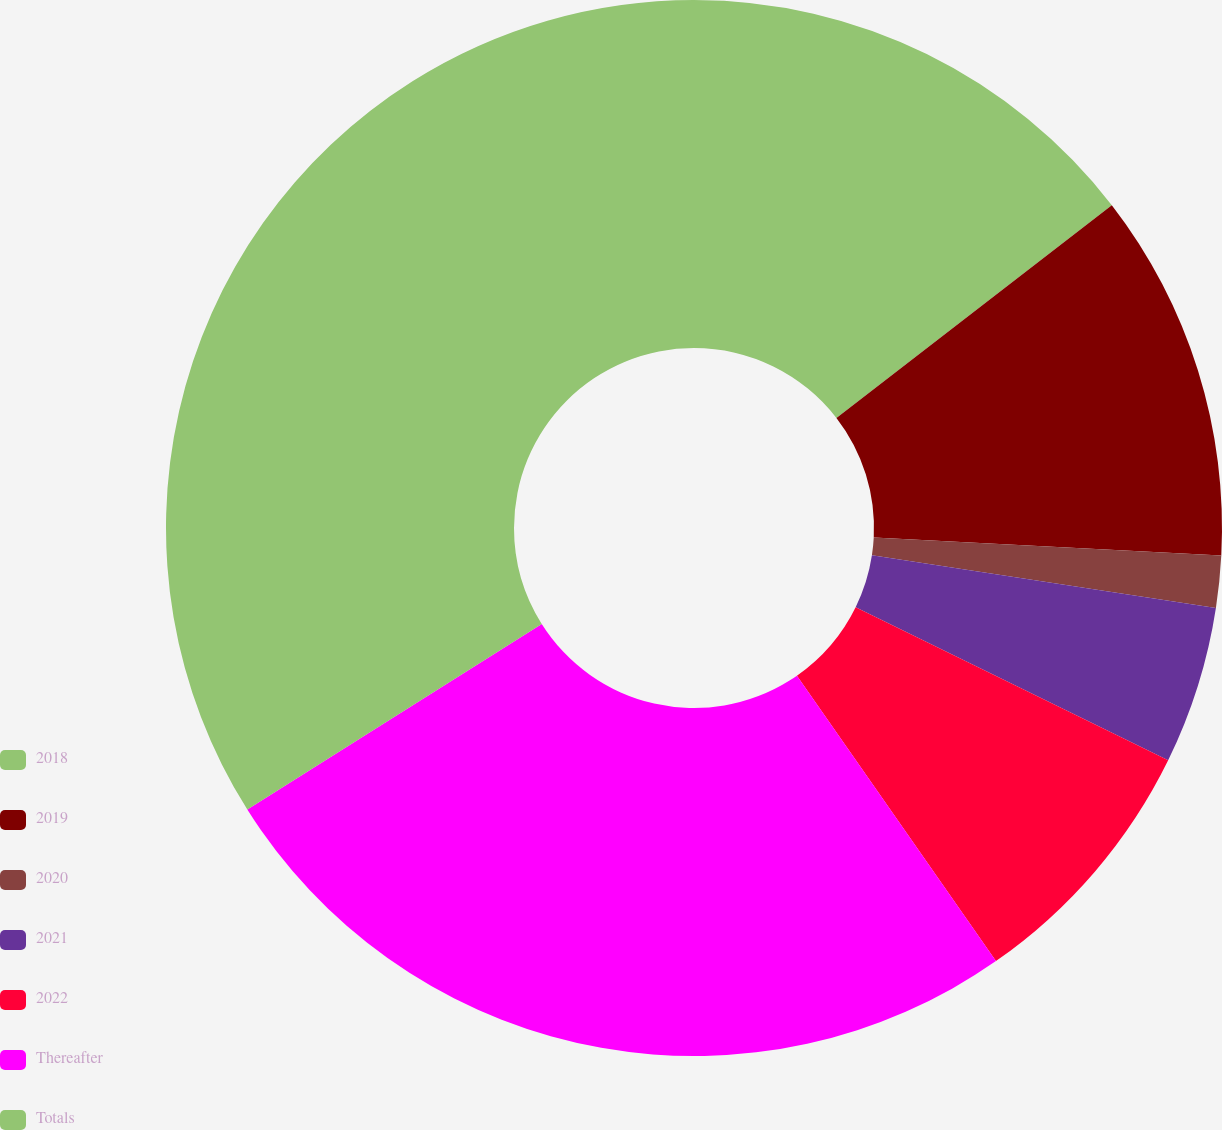<chart> <loc_0><loc_0><loc_500><loc_500><pie_chart><fcel>2018<fcel>2019<fcel>2020<fcel>2021<fcel>2022<fcel>Thereafter<fcel>Totals<nl><fcel>14.53%<fcel>11.3%<fcel>1.59%<fcel>4.83%<fcel>8.06%<fcel>25.74%<fcel>33.95%<nl></chart> 